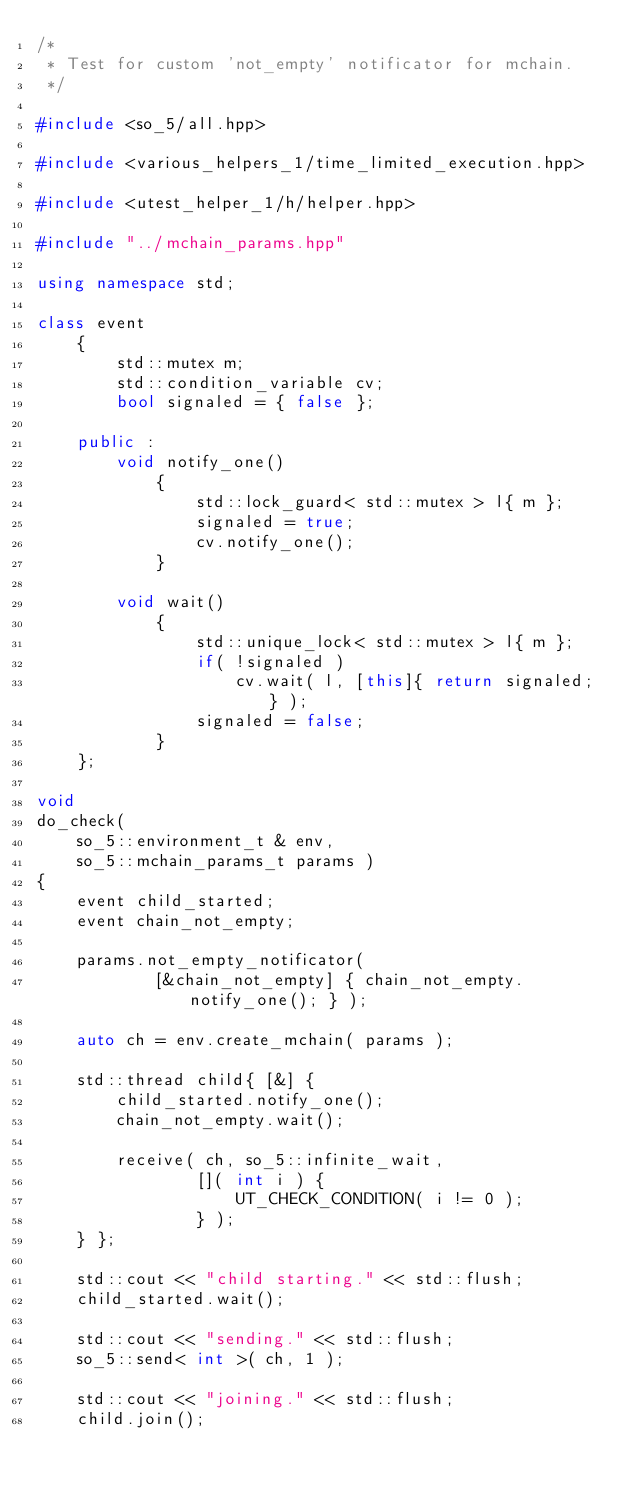<code> <loc_0><loc_0><loc_500><loc_500><_C++_>/*
 * Test for custom 'not_empty' notificator for mchain.
 */

#include <so_5/all.hpp>

#include <various_helpers_1/time_limited_execution.hpp>

#include <utest_helper_1/h/helper.hpp>

#include "../mchain_params.hpp"

using namespace std;

class event
	{
		std::mutex m;
		std::condition_variable cv;
		bool signaled = { false };

	public :
		void notify_one()
			{
				std::lock_guard< std::mutex > l{ m };
				signaled = true;
				cv.notify_one();
			}

		void wait()
			{
				std::unique_lock< std::mutex > l{ m };
				if( !signaled )
					cv.wait( l, [this]{ return signaled; } );
				signaled = false;
			}
	};

void
do_check(
	so_5::environment_t & env,
	so_5::mchain_params_t params )
{
	event child_started;
	event chain_not_empty;

	params.not_empty_notificator(
			[&chain_not_empty] { chain_not_empty.notify_one(); } );

	auto ch = env.create_mchain( params );

	std::thread child{ [&] {
		child_started.notify_one();
		chain_not_empty.wait();
		
		receive( ch, so_5::infinite_wait,
				[]( int i ) {
					UT_CHECK_CONDITION( i != 0 );
				} );
	} };

	std::cout << "child starting." << std::flush;
	child_started.wait();

	std::cout << "sending." << std::flush;
	so_5::send< int >( ch, 1 );

	std::cout << "joining." << std::flush;
	child.join();
</code> 